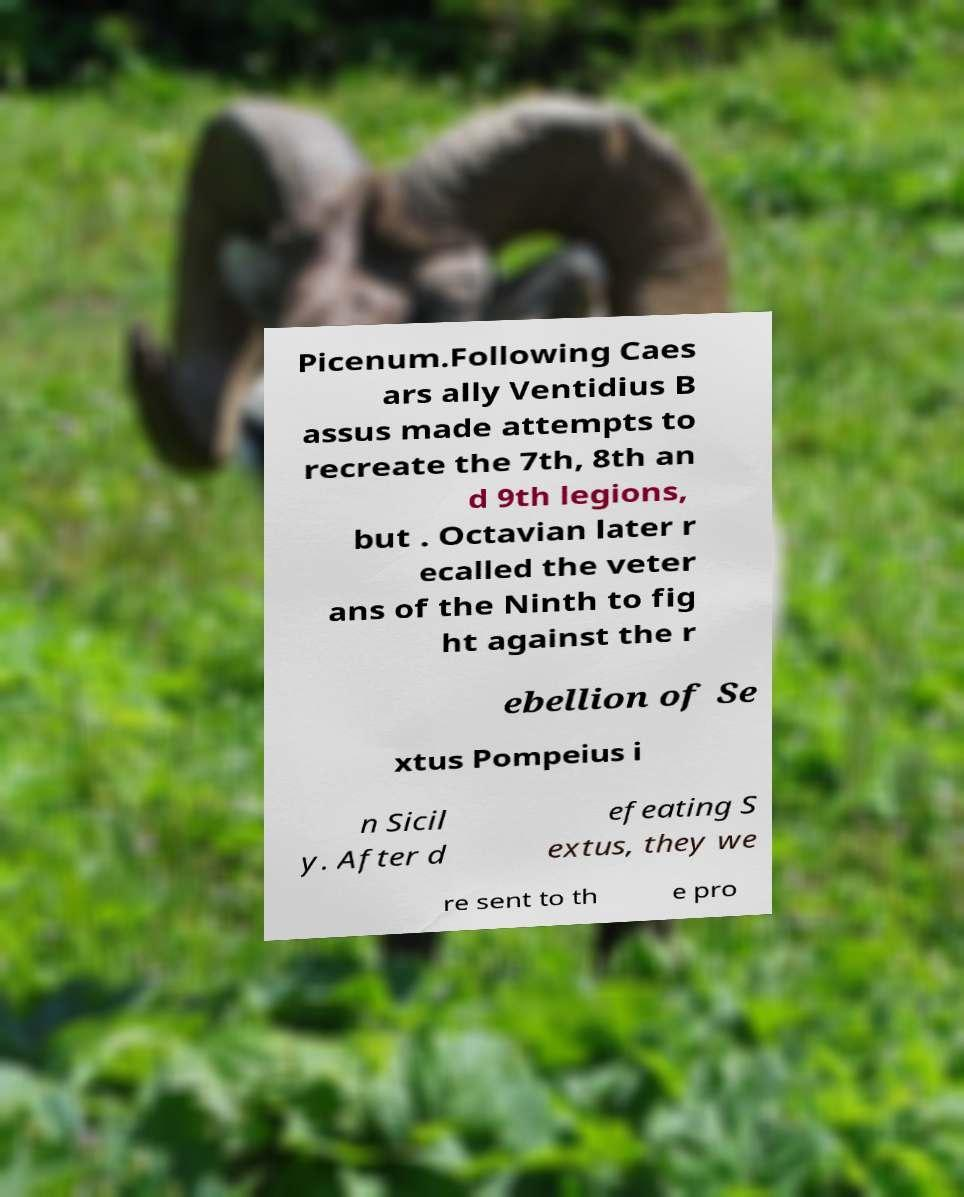Can you accurately transcribe the text from the provided image for me? Picenum.Following Caes ars ally Ventidius B assus made attempts to recreate the 7th, 8th an d 9th legions, but . Octavian later r ecalled the veter ans of the Ninth to fig ht against the r ebellion of Se xtus Pompeius i n Sicil y. After d efeating S extus, they we re sent to th e pro 